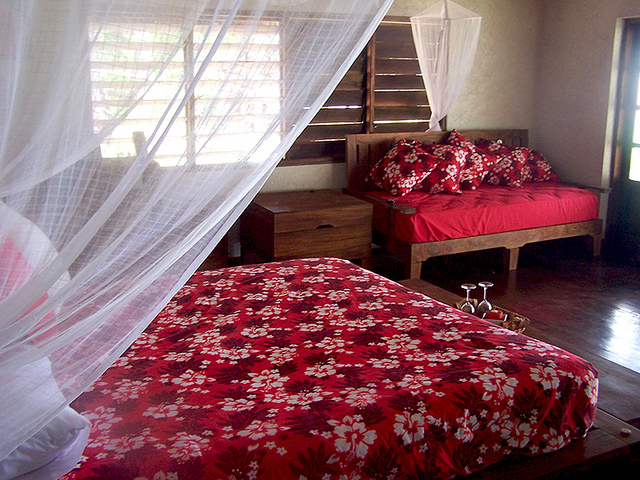What details can you gather about the room's functionality? This room functions as a bedroom, designed for rest and relaxation. Features like the mosquito netting around the beds suggest it's located in a region with insects, prioritizing comfort and protection. The side tables and the stairs hint at a multi-level living space, perhaps suggesting that the room is part of a larger residence or a guesthouse. Is there anything that indicates the room might serve multiple purposes? Aside from serving as a sleeping area, the presence of natural light and the serene ambiance could make it an inviting space for activities like reading or meditating. However, there's no overt indication of the room serving as a work or dining area, which suggests it's mainly dedicated to rest. 